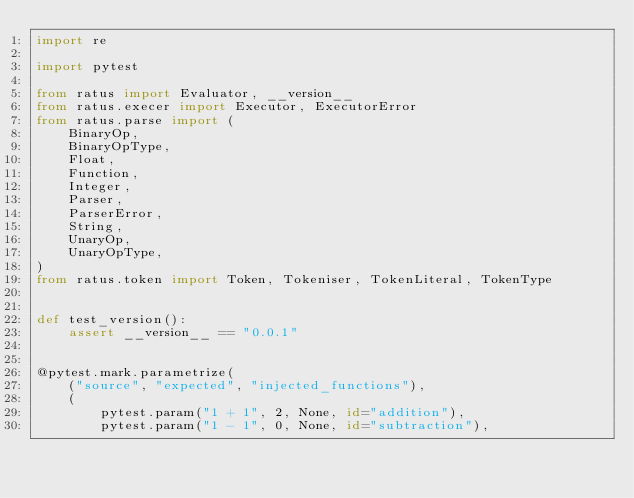<code> <loc_0><loc_0><loc_500><loc_500><_Python_>import re

import pytest

from ratus import Evaluator, __version__
from ratus.execer import Executor, ExecutorError
from ratus.parse import (
    BinaryOp,
    BinaryOpType,
    Float,
    Function,
    Integer,
    Parser,
    ParserError,
    String,
    UnaryOp,
    UnaryOpType,
)
from ratus.token import Token, Tokeniser, TokenLiteral, TokenType


def test_version():
    assert __version__ == "0.0.1"


@pytest.mark.parametrize(
    ("source", "expected", "injected_functions"),
    (
        pytest.param("1 + 1", 2, None, id="addition"),
        pytest.param("1 - 1", 0, None, id="subtraction"),</code> 